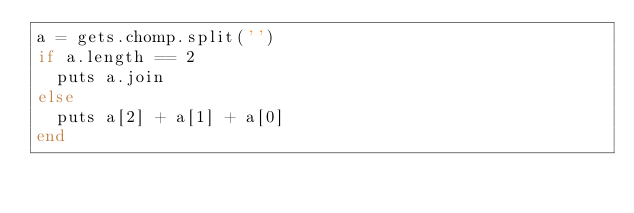Convert code to text. <code><loc_0><loc_0><loc_500><loc_500><_Ruby_>a = gets.chomp.split('')
if a.length == 2
  puts a.join
else
  puts a[2] + a[1] + a[0]
end</code> 